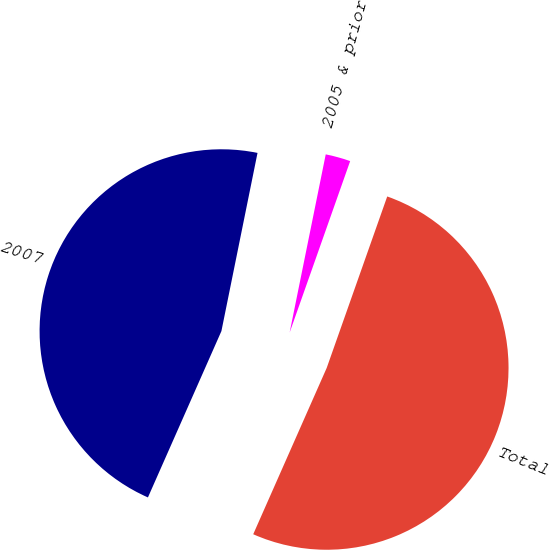Convert chart. <chart><loc_0><loc_0><loc_500><loc_500><pie_chart><fcel>2005 & prior<fcel>2007<fcel>Total<nl><fcel>2.22%<fcel>46.56%<fcel>51.22%<nl></chart> 